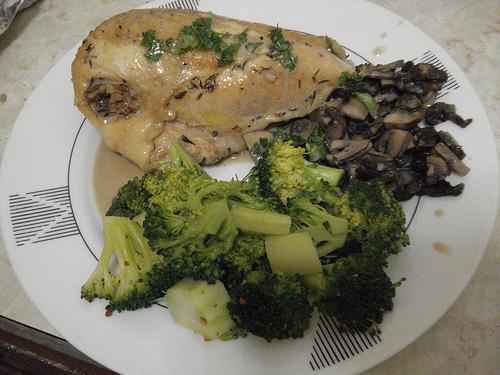How many plates are pictured?
Give a very brief answer. 1. 